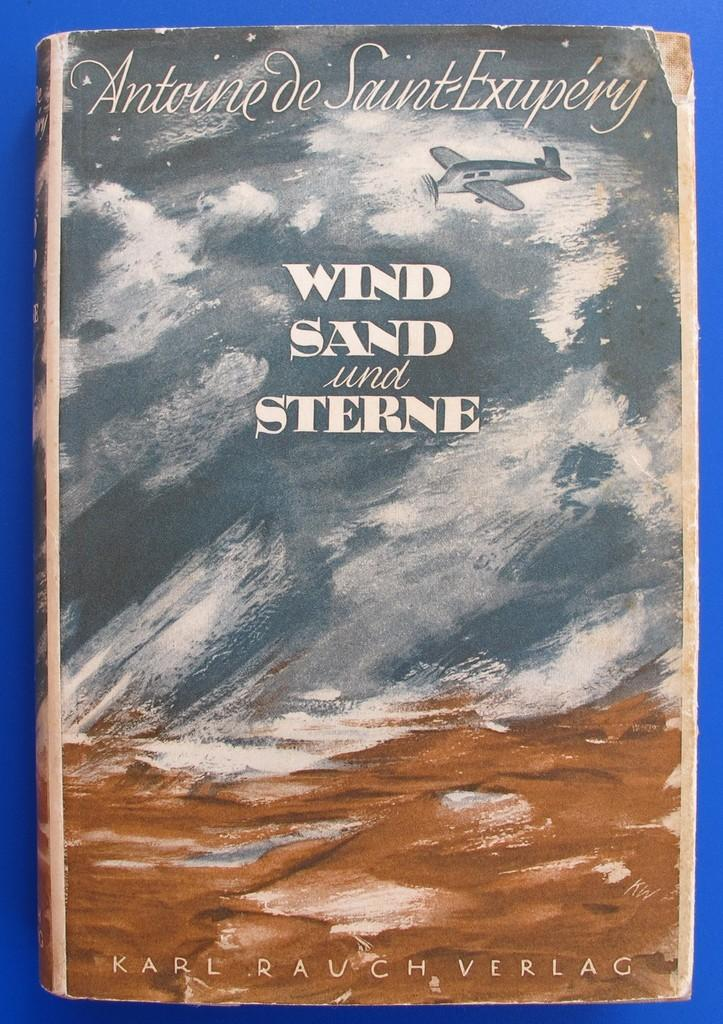<image>
Describe the image concisely. A faded book cover says Wind Sand and Sterne has an airplane on it. 